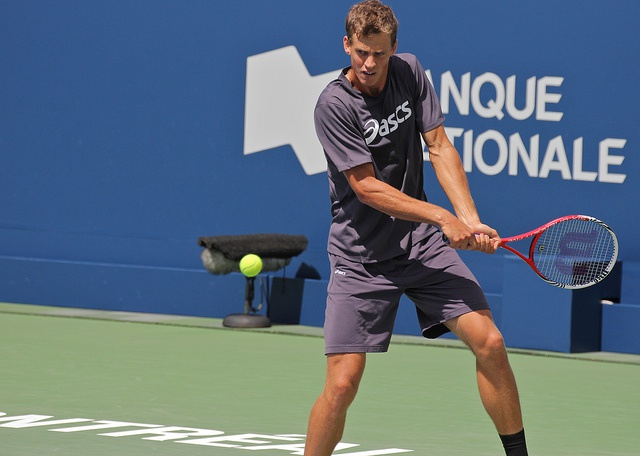Describe the objects in this image and their specific colors. I can see people in blue, black, gray, salmon, and brown tones, tennis racket in blue and gray tones, and sports ball in blue, khaki, olive, and lightgreen tones in this image. 